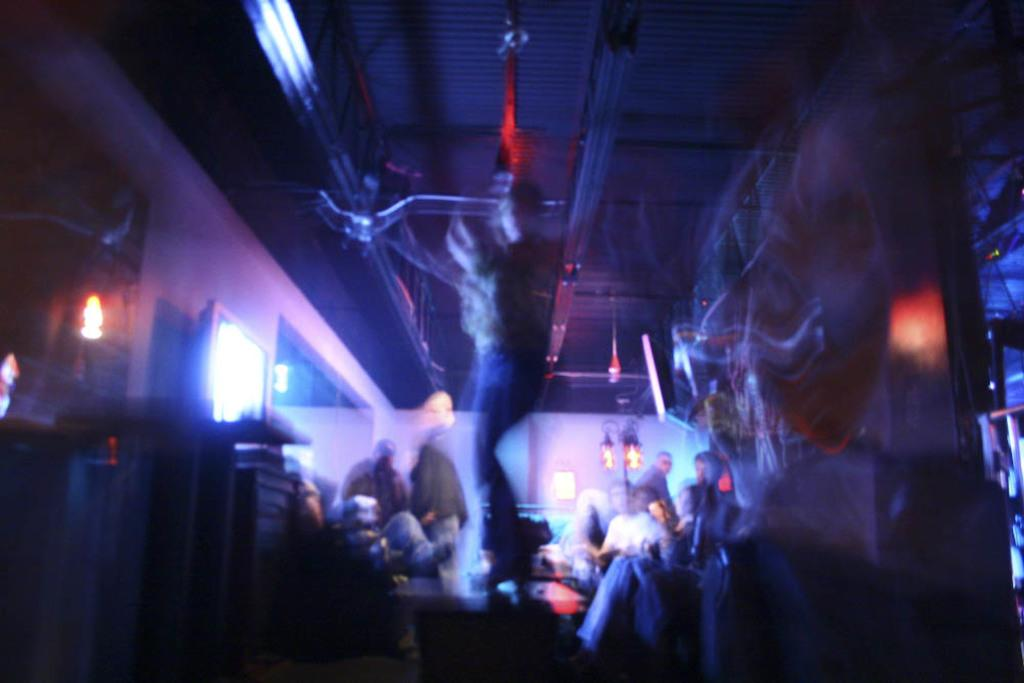What is the main subject of the image? There is a person standing in the center of the image. Are there any other people visible in the image? Yes, other people are present in the image. What can be seen on either side of the person? There are screens on either side of the person. Can you describe the quality of the image? The image is blurred. What type of brush is the person using in the image? There is no brush visible in the image. Can you read the note that the person is holding in the image? There is no note visible in the image. How many ducks are swimming in the pond in the image? There is no pond or ducks present in the image. 